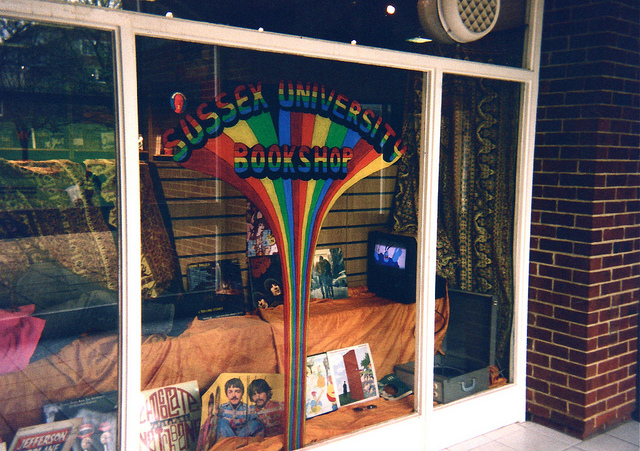Identify the text displayed in this image. SUSSEX BOO BOOK SHOP UNIVERSITY JEFFERSON CHOCOLATE CHOCOLATE 